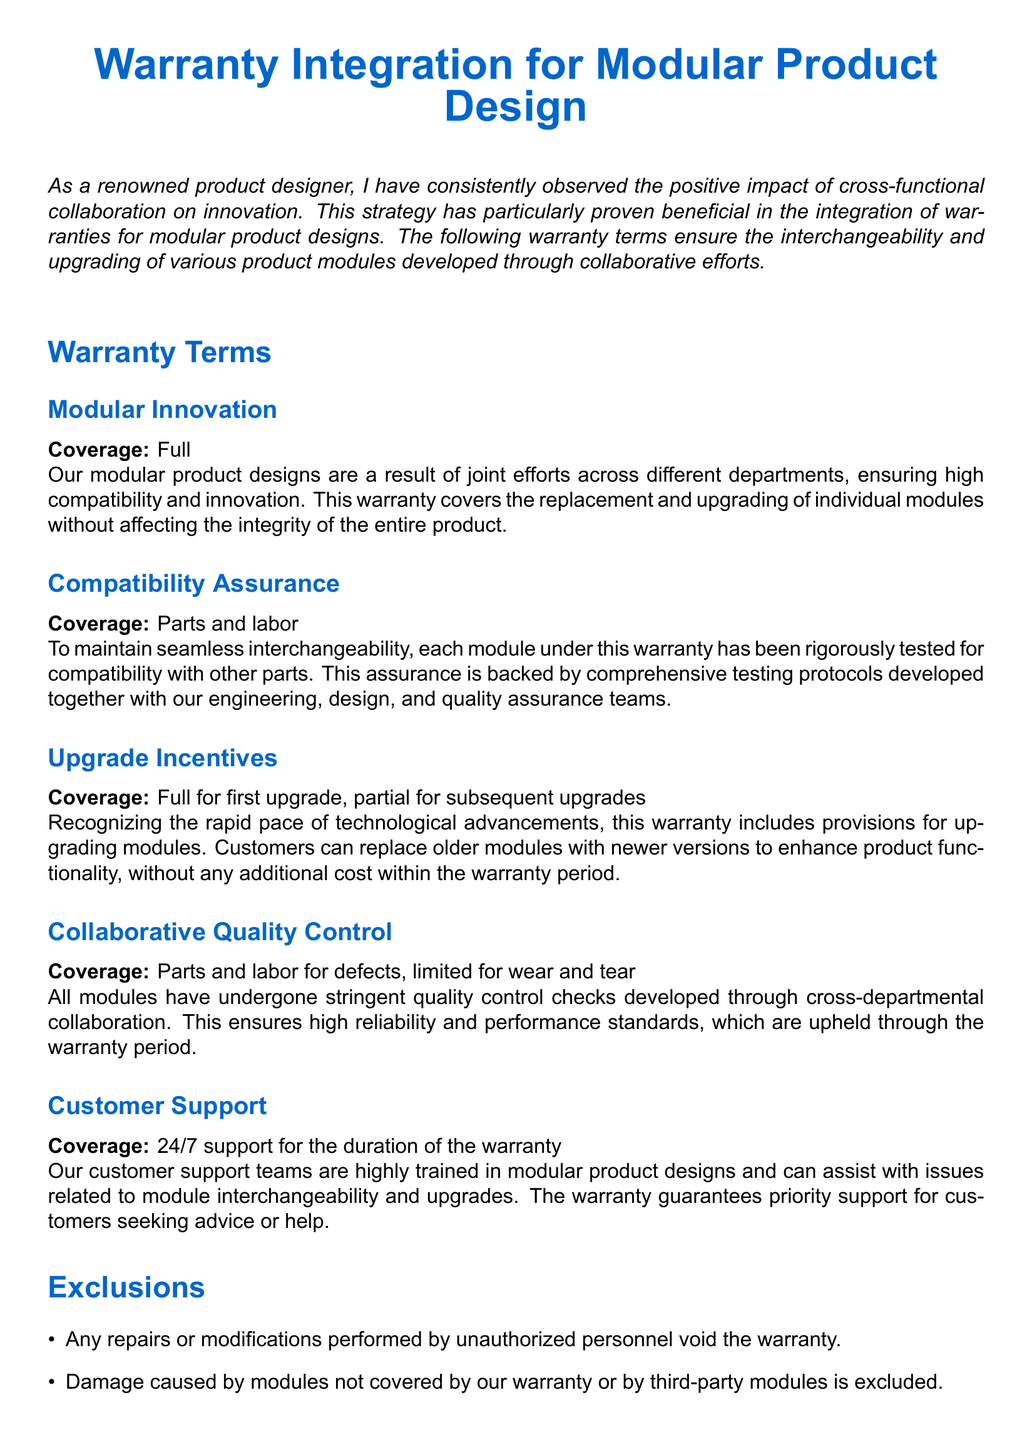What is the effective date of the warranty? The effective date is stated as the date of original purchase.
Answer: Date of original purchase What is the duration of the warranty? The duration is clearly mentioned as three years from the date of purchase or until the first major upgrade, whichever comes first.
Answer: Three years What is covered under Modular Innovation? The coverage under Modular Innovation involves replacement and upgrading of individual modules without affecting the integrity of the entire product.
Answer: Full What support is available through the warranty? The warranty guarantees 24/7 support from customer support teams specifically trained in modular product designs.
Answer: 24/7 support What happens for subsequent upgrades under the warranty? The warranty offers partial coverage for upgrades after the first one.
Answer: Partial for subsequent upgrades Who should be contacted for support? The contact email for support is provided in the document.
Answer: support@innovativedesigns.com What is excluded from the warranty regarding repairs? The warranty is void if repairs or modifications are performed by unauthorized personnel.
Answer: Unauthorized personnel How are modules tested for compatibility? The document states that compatibility is backed by comprehensive testing protocols developed collaboratively with various teams.
Answer: Comprehensive testing protocols What specific type of damages does the warranty not cover? The warranty does not cover damages resulting from environmental factors such as floods, fire, or earthquakes.
Answer: Environmental factors 